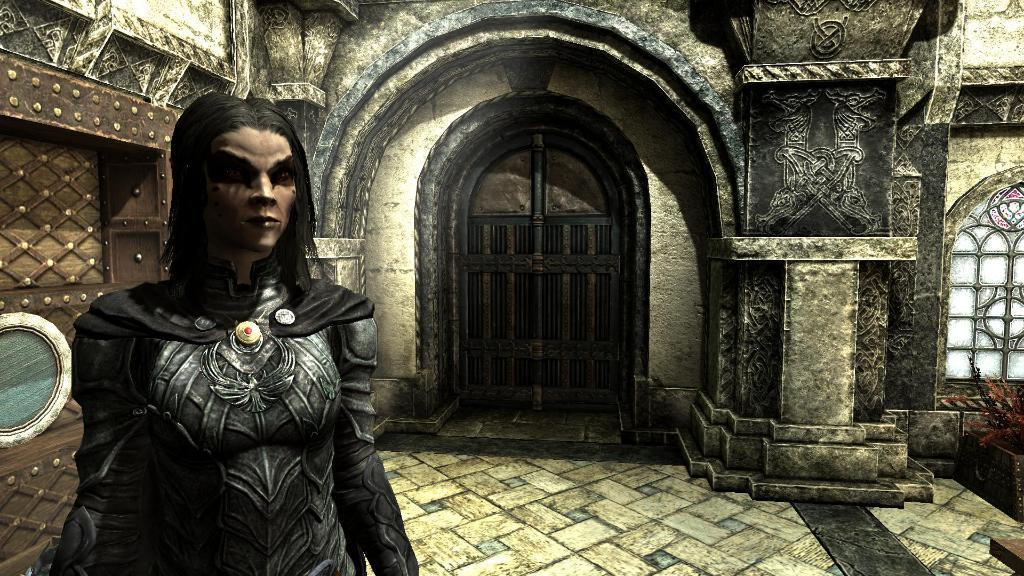What is the main subject in the foreground of the image? There is a person standing in the foreground of the image. Where is the person located in relation to the image? The person is on the left side of the image. What can be seen in the background of the image? There is a building, an arch, a floor, and a window visible in the background of the image. What type of card is being used to make a decision in the image? There is no card or decision-making process depicted in the image. What type of roof is visible on the building in the background? There is no roof visible on the building in the background; only the building's facade and an arch are visible. 